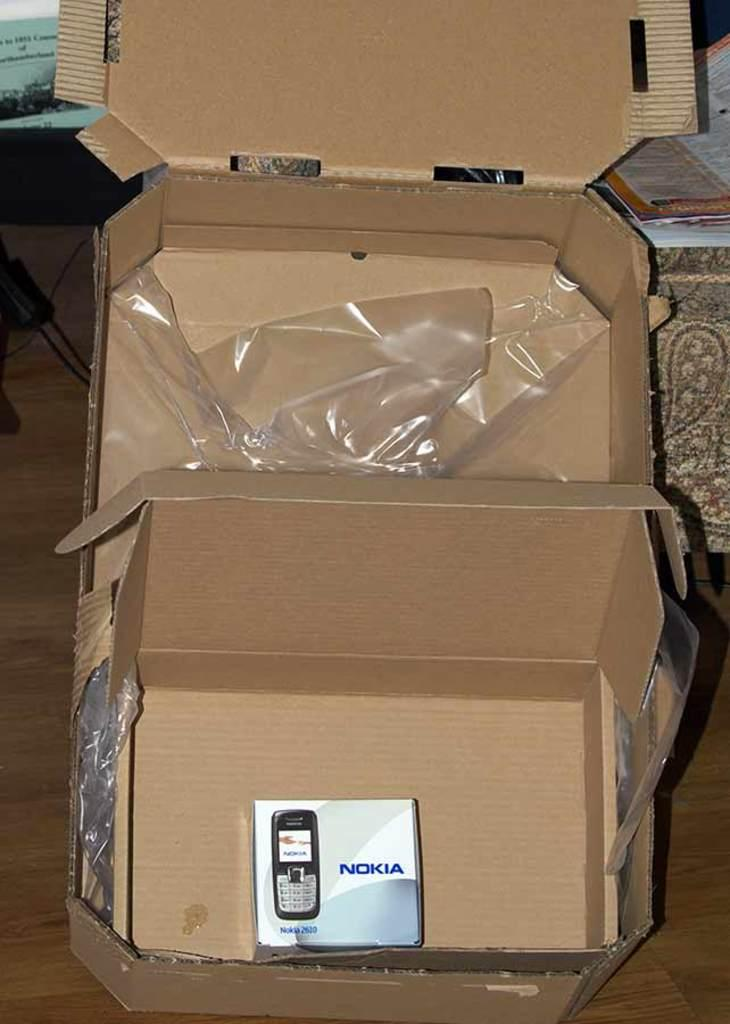What object is the main focus of the image? There is a cardboard box in the image. What is the color of the cardboard box? The cardboard box is brown in color. What can be seen in the background of the image? Papers are visible in the background of the image. What is the color of the surface in the background? The background surface is brown. What type of trousers is the expert wearing in the image? There is no expert or trousers present in the image; it only features a cardboard box and papers in the background. 